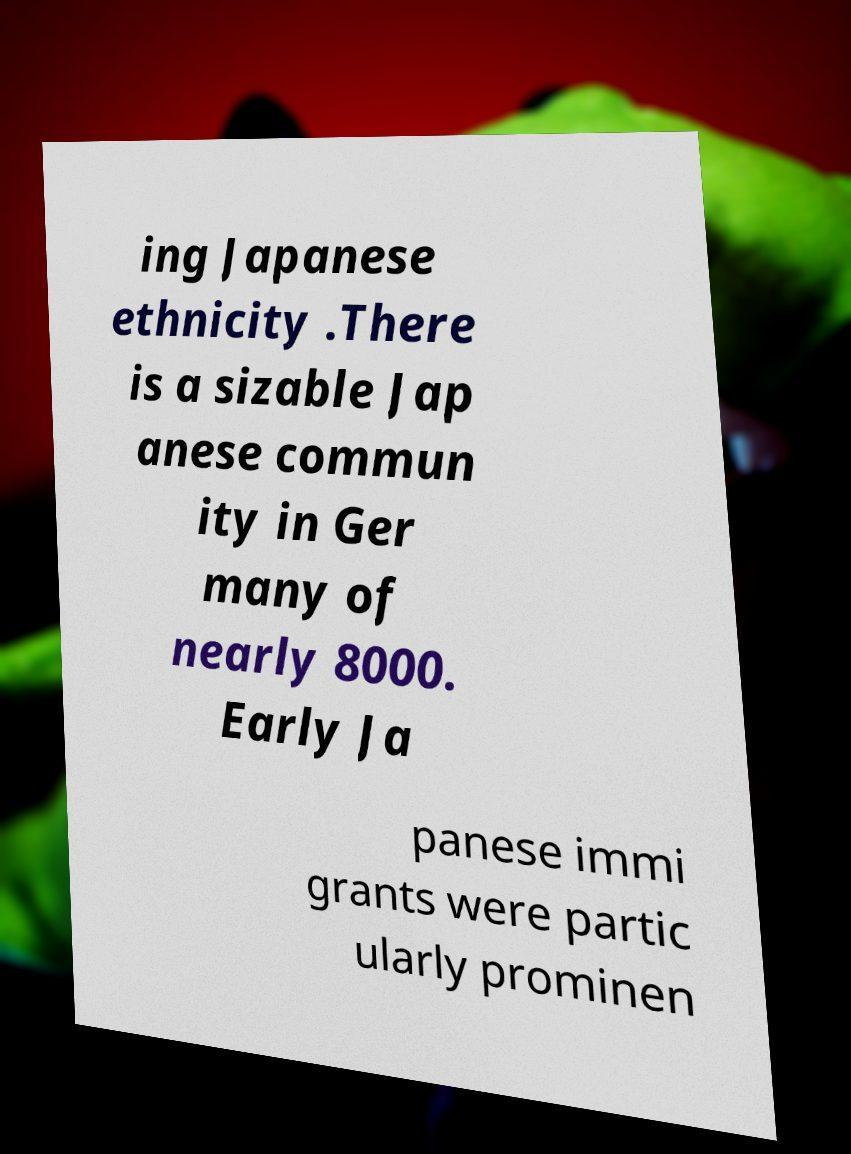Please read and relay the text visible in this image. What does it say? ing Japanese ethnicity .There is a sizable Jap anese commun ity in Ger many of nearly 8000. Early Ja panese immi grants were partic ularly prominen 